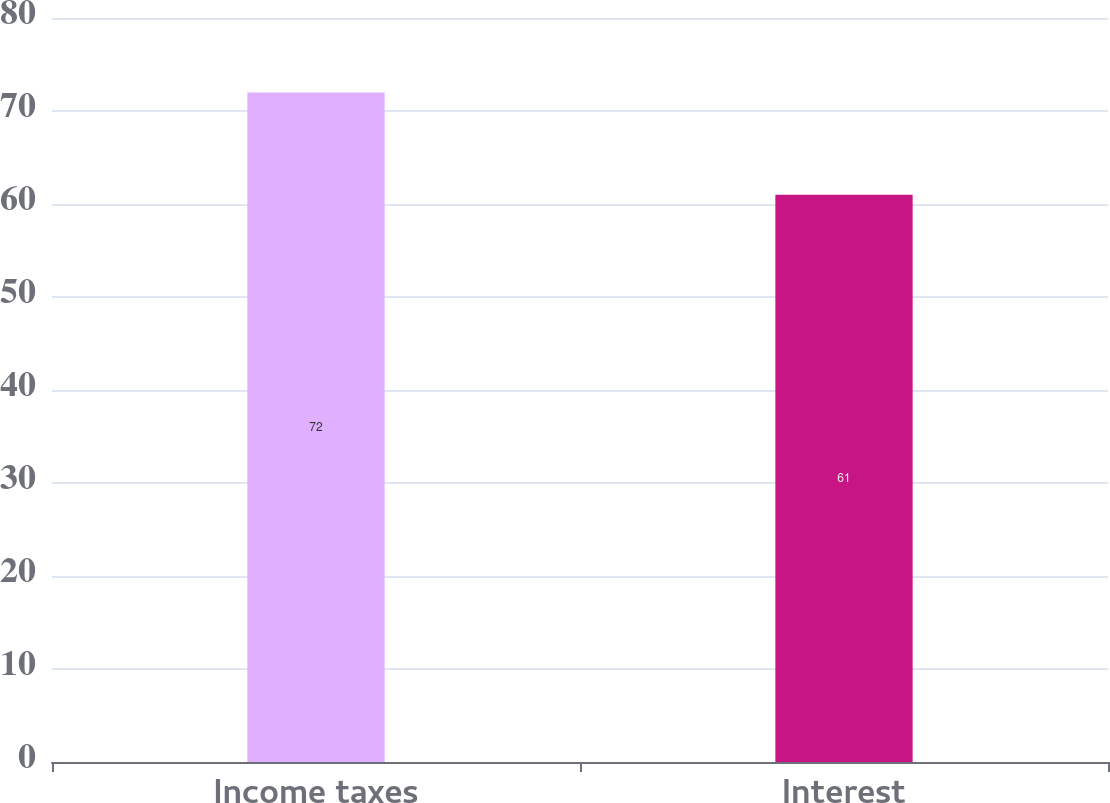Convert chart to OTSL. <chart><loc_0><loc_0><loc_500><loc_500><bar_chart><fcel>Income taxes<fcel>Interest<nl><fcel>72<fcel>61<nl></chart> 